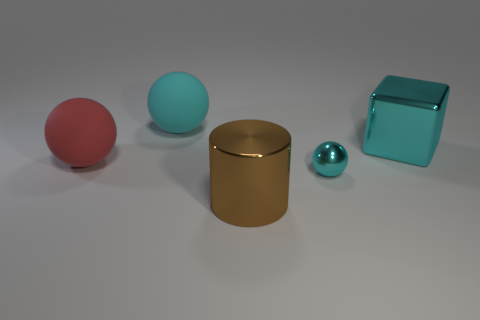Subtract all red cylinders. How many cyan spheres are left? 2 Add 1 big shiny things. How many objects exist? 6 Subtract all balls. How many objects are left? 2 Subtract all metal blocks. Subtract all red spheres. How many objects are left? 3 Add 5 cylinders. How many cylinders are left? 6 Add 3 small yellow rubber spheres. How many small yellow rubber spheres exist? 3 Subtract 1 brown cylinders. How many objects are left? 4 